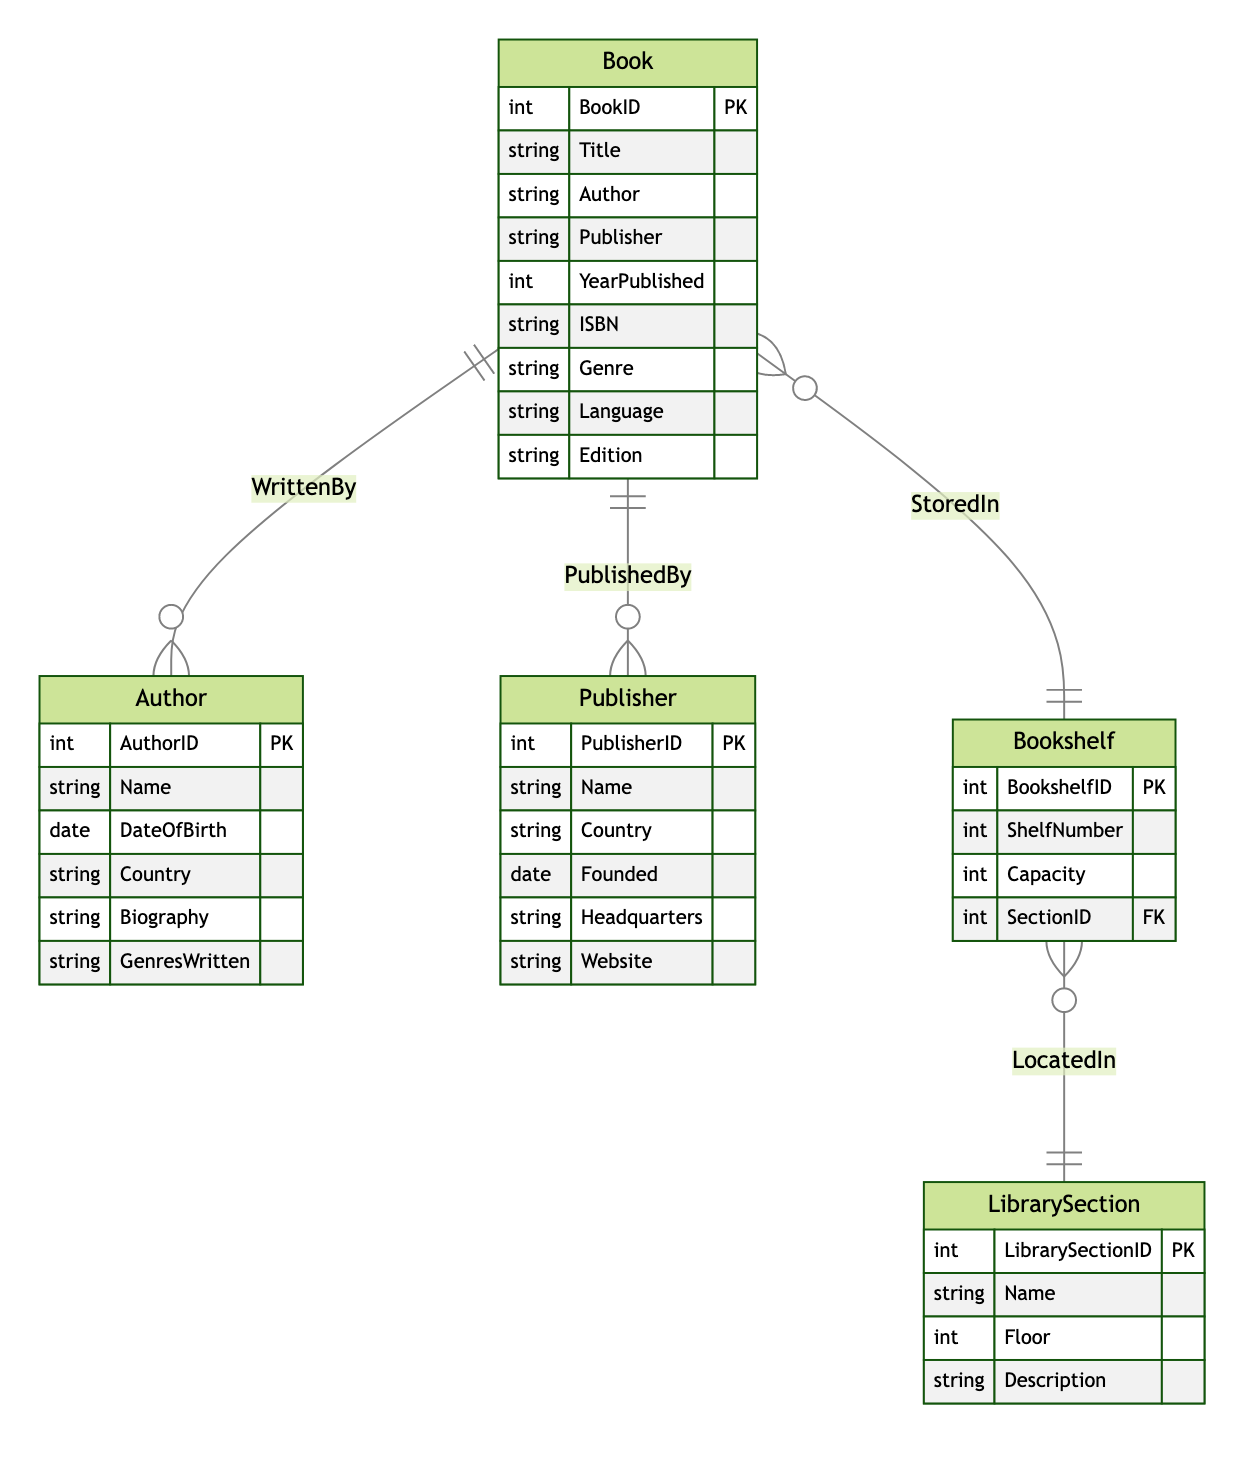What is the primary key of the Book entity? In the diagram, each entity has attributes defined, and for the Book entity, the primary key is labeled as "PK". The primary key for Book is BookID.
Answer: BookID How many relationships are there in this diagram? There are four relationships defined in the diagram, each connecting different entities: WrittenBy, PublishedBy, StoredIn, and LocatedIn. Counting these gives a total of four.
Answer: 4 Which entity is connected to the Author entity through the WrittenBy relationship? The WrittenBy relationship shows that the Book entity is linked to the Author entity. Specifically, this signifies that each book is written by one author.
Answer: Book What is the capacity of a Bookshelf? The Bookshelf entity includes an attribute labeled "Capacity" which indicates the maximum number of books it can hold. However, no specific numerical value is given in the provided data.
Answer: Capacity How many LibrarySection entities are there in the diagram? The diagram defines one LibrarySection entity explicitly, which includes various attributes. There are no additional sections indicated in the data provided.
Answer: 1 Which relationship connects the Bookshelf entity to the LibrarySection entity? The relationship that connects these two entities is named "LocatedIn". It indicates that each bookshelf has a designated section within the library.
Answer: LocatedIn What can be deduced about the relationship between Bookshelf and the LibrarySection? The relationship is many-to-one, indicating that multiple bookshelves can be located in a single library section, but each bookshelf belongs to only one section.
Answer: Many-to-one What type of information does the Author entity include? The Author entity consists of several attributes including Name, DateOfBirth, Country, Biography, and GenresWritten, which describe different aspects of an author’s background.
Answer: Descriptive attributes Which entities are connected by the StoredIn relationship? The StoredIn relationship connects the Book entity to the Bookshelf entity, indicating that books are stored within bookshelves in the library.
Answer: Book and Bookshelf 